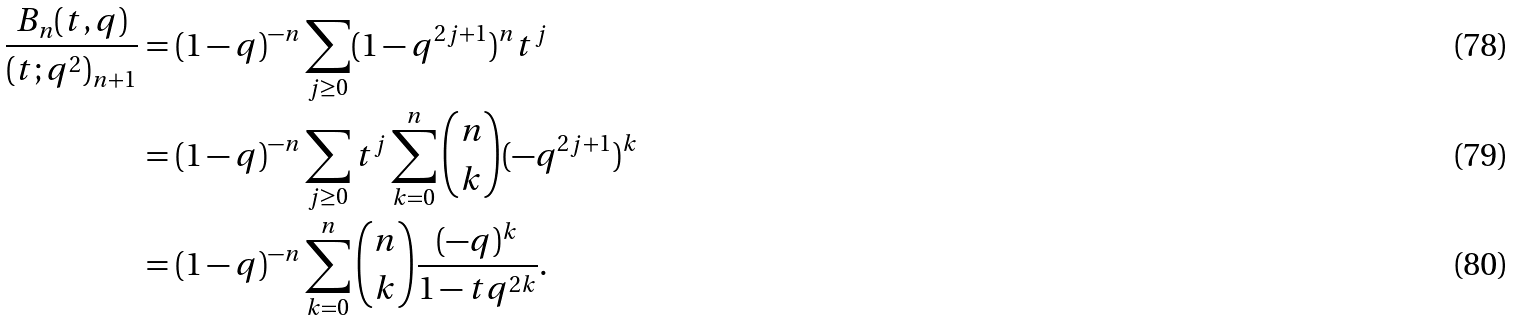Convert formula to latex. <formula><loc_0><loc_0><loc_500><loc_500>\frac { B _ { n } ( t , q ) } { ( t ; q ^ { 2 } ) _ { n + 1 } } & = ( 1 - q ) ^ { - n } \sum _ { j \geq 0 } ( 1 - q ^ { 2 j + 1 } ) ^ { n } t ^ { j } \\ & = ( 1 - q ) ^ { - n } \sum _ { j \geq 0 } t ^ { j } \sum _ { k = 0 } ^ { n } { n \choose k } ( - q ^ { 2 j + 1 } ) ^ { k } \\ & = ( 1 - q ) ^ { - n } \sum _ { k = 0 } ^ { n } { n \choose k } \frac { ( - q ) ^ { k } } { 1 - t q ^ { 2 k } } .</formula> 